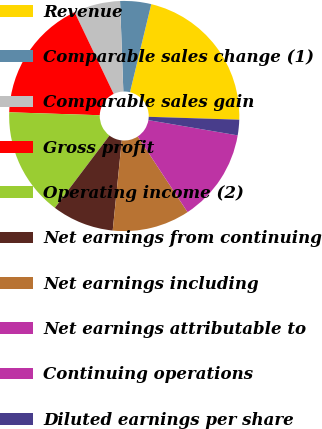Convert chart. <chart><loc_0><loc_0><loc_500><loc_500><pie_chart><fcel>Revenue<fcel>Comparable sales change (1)<fcel>Comparable sales gain<fcel>Gross profit<fcel>Operating income (2)<fcel>Net earnings from continuing<fcel>Net earnings including<fcel>Net earnings attributable to<fcel>Continuing operations<fcel>Diluted earnings per share<nl><fcel>21.74%<fcel>4.35%<fcel>6.52%<fcel>17.39%<fcel>15.22%<fcel>8.7%<fcel>10.87%<fcel>13.04%<fcel>0.0%<fcel>2.18%<nl></chart> 